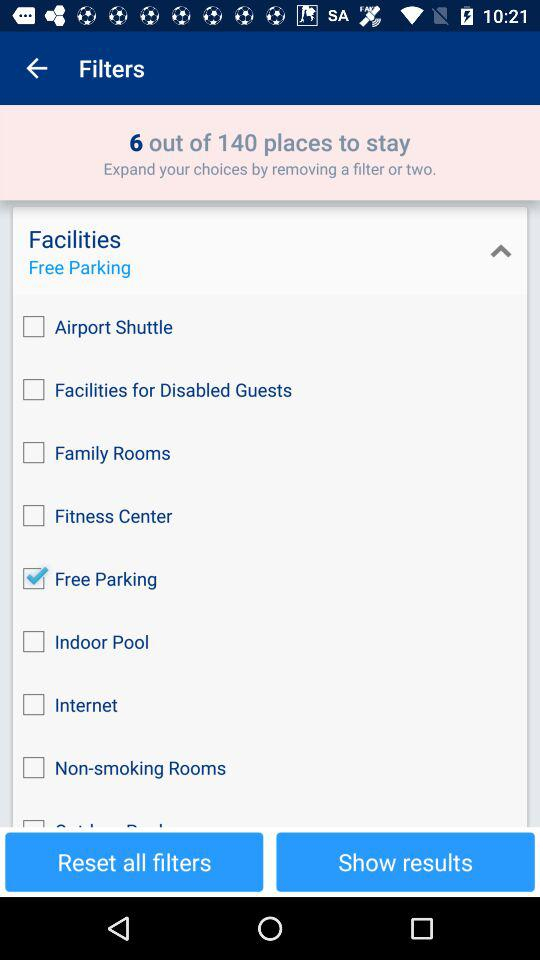How many filters have been applied?
Answer the question using a single word or phrase. 9 